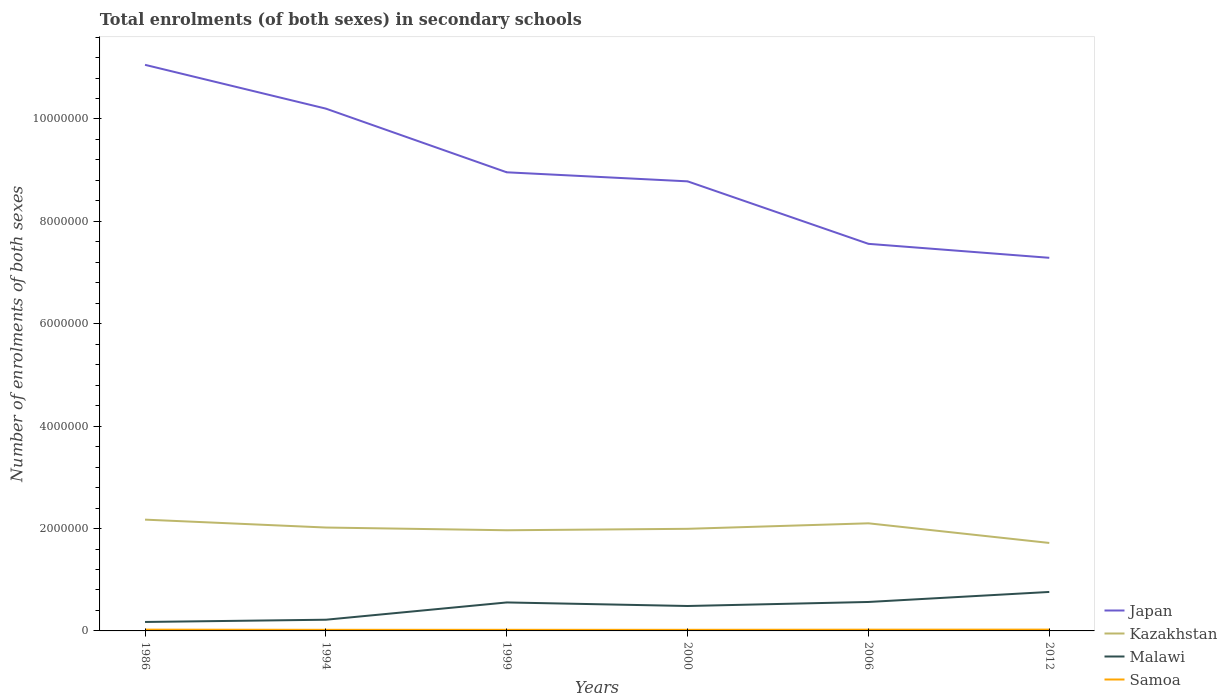How many different coloured lines are there?
Give a very brief answer. 4. Across all years, what is the maximum number of enrolments in secondary schools in Samoa?
Ensure brevity in your answer.  2.17e+04. What is the total number of enrolments in secondary schools in Samoa in the graph?
Provide a succinct answer. -3773. What is the difference between the highest and the second highest number of enrolments in secondary schools in Japan?
Your response must be concise. 3.77e+06. Is the number of enrolments in secondary schools in Malawi strictly greater than the number of enrolments in secondary schools in Kazakhstan over the years?
Ensure brevity in your answer.  Yes. How many lines are there?
Give a very brief answer. 4. How many years are there in the graph?
Give a very brief answer. 6. Does the graph contain any zero values?
Your answer should be compact. No. Does the graph contain grids?
Make the answer very short. No. What is the title of the graph?
Give a very brief answer. Total enrolments (of both sexes) in secondary schools. Does "Nepal" appear as one of the legend labels in the graph?
Make the answer very short. No. What is the label or title of the X-axis?
Provide a short and direct response. Years. What is the label or title of the Y-axis?
Make the answer very short. Number of enrolments of both sexes. What is the Number of enrolments of both sexes in Japan in 1986?
Provide a succinct answer. 1.11e+07. What is the Number of enrolments of both sexes in Kazakhstan in 1986?
Make the answer very short. 2.17e+06. What is the Number of enrolments of both sexes in Malawi in 1986?
Give a very brief answer. 1.75e+05. What is the Number of enrolments of both sexes of Samoa in 1986?
Make the answer very short. 2.51e+04. What is the Number of enrolments of both sexes in Japan in 1994?
Your response must be concise. 1.02e+07. What is the Number of enrolments of both sexes of Kazakhstan in 1994?
Your answer should be very brief. 2.02e+06. What is the Number of enrolments of both sexes in Malawi in 1994?
Provide a short and direct response. 2.19e+05. What is the Number of enrolments of both sexes of Samoa in 1994?
Keep it short and to the point. 2.18e+04. What is the Number of enrolments of both sexes in Japan in 1999?
Your answer should be very brief. 8.96e+06. What is the Number of enrolments of both sexes of Kazakhstan in 1999?
Offer a terse response. 1.97e+06. What is the Number of enrolments of both sexes in Malawi in 1999?
Provide a short and direct response. 5.56e+05. What is the Number of enrolments of both sexes of Samoa in 1999?
Offer a terse response. 2.17e+04. What is the Number of enrolments of both sexes in Japan in 2000?
Ensure brevity in your answer.  8.78e+06. What is the Number of enrolments of both sexes of Kazakhstan in 2000?
Make the answer very short. 1.99e+06. What is the Number of enrolments of both sexes in Malawi in 2000?
Keep it short and to the point. 4.87e+05. What is the Number of enrolments of both sexes in Samoa in 2000?
Ensure brevity in your answer.  2.17e+04. What is the Number of enrolments of both sexes of Japan in 2006?
Offer a very short reply. 7.56e+06. What is the Number of enrolments of both sexes in Kazakhstan in 2006?
Provide a short and direct response. 2.10e+06. What is the Number of enrolments of both sexes of Malawi in 2006?
Offer a very short reply. 5.65e+05. What is the Number of enrolments of both sexes in Samoa in 2006?
Offer a terse response. 2.44e+04. What is the Number of enrolments of both sexes of Japan in 2012?
Provide a short and direct response. 7.29e+06. What is the Number of enrolments of both sexes in Kazakhstan in 2012?
Provide a short and direct response. 1.72e+06. What is the Number of enrolments of both sexes of Malawi in 2012?
Your answer should be compact. 7.61e+05. What is the Number of enrolments of both sexes of Samoa in 2012?
Provide a short and direct response. 2.56e+04. Across all years, what is the maximum Number of enrolments of both sexes of Japan?
Offer a terse response. 1.11e+07. Across all years, what is the maximum Number of enrolments of both sexes in Kazakhstan?
Your response must be concise. 2.17e+06. Across all years, what is the maximum Number of enrolments of both sexes of Malawi?
Make the answer very short. 7.61e+05. Across all years, what is the maximum Number of enrolments of both sexes of Samoa?
Give a very brief answer. 2.56e+04. Across all years, what is the minimum Number of enrolments of both sexes of Japan?
Give a very brief answer. 7.29e+06. Across all years, what is the minimum Number of enrolments of both sexes in Kazakhstan?
Ensure brevity in your answer.  1.72e+06. Across all years, what is the minimum Number of enrolments of both sexes in Malawi?
Provide a short and direct response. 1.75e+05. Across all years, what is the minimum Number of enrolments of both sexes in Samoa?
Provide a short and direct response. 2.17e+04. What is the total Number of enrolments of both sexes of Japan in the graph?
Your response must be concise. 5.39e+07. What is the total Number of enrolments of both sexes in Kazakhstan in the graph?
Offer a terse response. 1.20e+07. What is the total Number of enrolments of both sexes of Malawi in the graph?
Ensure brevity in your answer.  2.76e+06. What is the total Number of enrolments of both sexes of Samoa in the graph?
Offer a very short reply. 1.40e+05. What is the difference between the Number of enrolments of both sexes in Japan in 1986 and that in 1994?
Make the answer very short. 8.56e+05. What is the difference between the Number of enrolments of both sexes in Kazakhstan in 1986 and that in 1994?
Ensure brevity in your answer.  1.54e+05. What is the difference between the Number of enrolments of both sexes in Malawi in 1986 and that in 1994?
Offer a terse response. -4.40e+04. What is the difference between the Number of enrolments of both sexes of Samoa in 1986 and that in 1994?
Your answer should be very brief. 3304. What is the difference between the Number of enrolments of both sexes of Japan in 1986 and that in 1999?
Your response must be concise. 2.10e+06. What is the difference between the Number of enrolments of both sexes of Kazakhstan in 1986 and that in 1999?
Your answer should be very brief. 2.07e+05. What is the difference between the Number of enrolments of both sexes of Malawi in 1986 and that in 1999?
Provide a succinct answer. -3.82e+05. What is the difference between the Number of enrolments of both sexes of Samoa in 1986 and that in 1999?
Keep it short and to the point. 3347. What is the difference between the Number of enrolments of both sexes of Japan in 1986 and that in 2000?
Offer a very short reply. 2.28e+06. What is the difference between the Number of enrolments of both sexes in Kazakhstan in 1986 and that in 2000?
Keep it short and to the point. 1.79e+05. What is the difference between the Number of enrolments of both sexes in Malawi in 1986 and that in 2000?
Offer a very short reply. -3.12e+05. What is the difference between the Number of enrolments of both sexes in Samoa in 1986 and that in 2000?
Ensure brevity in your answer.  3414. What is the difference between the Number of enrolments of both sexes in Japan in 1986 and that in 2006?
Keep it short and to the point. 3.50e+06. What is the difference between the Number of enrolments of both sexes of Kazakhstan in 1986 and that in 2006?
Keep it short and to the point. 7.17e+04. What is the difference between the Number of enrolments of both sexes in Malawi in 1986 and that in 2006?
Give a very brief answer. -3.91e+05. What is the difference between the Number of enrolments of both sexes in Samoa in 1986 and that in 2006?
Your answer should be compact. 705. What is the difference between the Number of enrolments of both sexes of Japan in 1986 and that in 2012?
Make the answer very short. 3.77e+06. What is the difference between the Number of enrolments of both sexes of Kazakhstan in 1986 and that in 2012?
Ensure brevity in your answer.  4.55e+05. What is the difference between the Number of enrolments of both sexes of Malawi in 1986 and that in 2012?
Keep it short and to the point. -5.87e+05. What is the difference between the Number of enrolments of both sexes of Samoa in 1986 and that in 2012?
Provide a short and direct response. -469. What is the difference between the Number of enrolments of both sexes in Japan in 1994 and that in 1999?
Make the answer very short. 1.24e+06. What is the difference between the Number of enrolments of both sexes of Kazakhstan in 1994 and that in 1999?
Make the answer very short. 5.32e+04. What is the difference between the Number of enrolments of both sexes in Malawi in 1994 and that in 1999?
Your response must be concise. -3.38e+05. What is the difference between the Number of enrolments of both sexes in Samoa in 1994 and that in 1999?
Your answer should be very brief. 43. What is the difference between the Number of enrolments of both sexes of Japan in 1994 and that in 2000?
Offer a terse response. 1.42e+06. What is the difference between the Number of enrolments of both sexes of Kazakhstan in 1994 and that in 2000?
Provide a short and direct response. 2.52e+04. What is the difference between the Number of enrolments of both sexes of Malawi in 1994 and that in 2000?
Keep it short and to the point. -2.68e+05. What is the difference between the Number of enrolments of both sexes of Samoa in 1994 and that in 2000?
Your response must be concise. 110. What is the difference between the Number of enrolments of both sexes of Japan in 1994 and that in 2006?
Ensure brevity in your answer.  2.64e+06. What is the difference between the Number of enrolments of both sexes in Kazakhstan in 1994 and that in 2006?
Your answer should be very brief. -8.25e+04. What is the difference between the Number of enrolments of both sexes of Malawi in 1994 and that in 2006?
Provide a succinct answer. -3.47e+05. What is the difference between the Number of enrolments of both sexes in Samoa in 1994 and that in 2006?
Your answer should be very brief. -2599. What is the difference between the Number of enrolments of both sexes in Japan in 1994 and that in 2012?
Offer a very short reply. 2.91e+06. What is the difference between the Number of enrolments of both sexes in Kazakhstan in 1994 and that in 2012?
Your response must be concise. 3.01e+05. What is the difference between the Number of enrolments of both sexes of Malawi in 1994 and that in 2012?
Offer a terse response. -5.43e+05. What is the difference between the Number of enrolments of both sexes of Samoa in 1994 and that in 2012?
Your answer should be very brief. -3773. What is the difference between the Number of enrolments of both sexes of Japan in 1999 and that in 2000?
Provide a short and direct response. 1.77e+05. What is the difference between the Number of enrolments of both sexes of Kazakhstan in 1999 and that in 2000?
Ensure brevity in your answer.  -2.80e+04. What is the difference between the Number of enrolments of both sexes of Malawi in 1999 and that in 2000?
Make the answer very short. 6.95e+04. What is the difference between the Number of enrolments of both sexes of Japan in 1999 and that in 2006?
Your answer should be compact. 1.40e+06. What is the difference between the Number of enrolments of both sexes of Kazakhstan in 1999 and that in 2006?
Your answer should be very brief. -1.36e+05. What is the difference between the Number of enrolments of both sexes in Malawi in 1999 and that in 2006?
Keep it short and to the point. -9145. What is the difference between the Number of enrolments of both sexes of Samoa in 1999 and that in 2006?
Your answer should be very brief. -2642. What is the difference between the Number of enrolments of both sexes in Japan in 1999 and that in 2012?
Give a very brief answer. 1.67e+06. What is the difference between the Number of enrolments of both sexes of Kazakhstan in 1999 and that in 2012?
Offer a very short reply. 2.48e+05. What is the difference between the Number of enrolments of both sexes in Malawi in 1999 and that in 2012?
Your response must be concise. -2.05e+05. What is the difference between the Number of enrolments of both sexes in Samoa in 1999 and that in 2012?
Give a very brief answer. -3816. What is the difference between the Number of enrolments of both sexes of Japan in 2000 and that in 2006?
Make the answer very short. 1.22e+06. What is the difference between the Number of enrolments of both sexes of Kazakhstan in 2000 and that in 2006?
Provide a succinct answer. -1.08e+05. What is the difference between the Number of enrolments of both sexes in Malawi in 2000 and that in 2006?
Provide a short and direct response. -7.87e+04. What is the difference between the Number of enrolments of both sexes in Samoa in 2000 and that in 2006?
Offer a very short reply. -2709. What is the difference between the Number of enrolments of both sexes in Japan in 2000 and that in 2012?
Offer a very short reply. 1.49e+06. What is the difference between the Number of enrolments of both sexes of Kazakhstan in 2000 and that in 2012?
Offer a terse response. 2.76e+05. What is the difference between the Number of enrolments of both sexes in Malawi in 2000 and that in 2012?
Give a very brief answer. -2.75e+05. What is the difference between the Number of enrolments of both sexes of Samoa in 2000 and that in 2012?
Offer a terse response. -3883. What is the difference between the Number of enrolments of both sexes of Japan in 2006 and that in 2012?
Give a very brief answer. 2.73e+05. What is the difference between the Number of enrolments of both sexes of Kazakhstan in 2006 and that in 2012?
Provide a succinct answer. 3.84e+05. What is the difference between the Number of enrolments of both sexes in Malawi in 2006 and that in 2012?
Provide a short and direct response. -1.96e+05. What is the difference between the Number of enrolments of both sexes of Samoa in 2006 and that in 2012?
Give a very brief answer. -1174. What is the difference between the Number of enrolments of both sexes in Japan in 1986 and the Number of enrolments of both sexes in Kazakhstan in 1994?
Make the answer very short. 9.04e+06. What is the difference between the Number of enrolments of both sexes in Japan in 1986 and the Number of enrolments of both sexes in Malawi in 1994?
Make the answer very short. 1.08e+07. What is the difference between the Number of enrolments of both sexes in Japan in 1986 and the Number of enrolments of both sexes in Samoa in 1994?
Offer a terse response. 1.10e+07. What is the difference between the Number of enrolments of both sexes in Kazakhstan in 1986 and the Number of enrolments of both sexes in Malawi in 1994?
Give a very brief answer. 1.96e+06. What is the difference between the Number of enrolments of both sexes in Kazakhstan in 1986 and the Number of enrolments of both sexes in Samoa in 1994?
Keep it short and to the point. 2.15e+06. What is the difference between the Number of enrolments of both sexes in Malawi in 1986 and the Number of enrolments of both sexes in Samoa in 1994?
Your response must be concise. 1.53e+05. What is the difference between the Number of enrolments of both sexes in Japan in 1986 and the Number of enrolments of both sexes in Kazakhstan in 1999?
Ensure brevity in your answer.  9.09e+06. What is the difference between the Number of enrolments of both sexes of Japan in 1986 and the Number of enrolments of both sexes of Malawi in 1999?
Provide a short and direct response. 1.05e+07. What is the difference between the Number of enrolments of both sexes of Japan in 1986 and the Number of enrolments of both sexes of Samoa in 1999?
Your answer should be compact. 1.10e+07. What is the difference between the Number of enrolments of both sexes in Kazakhstan in 1986 and the Number of enrolments of both sexes in Malawi in 1999?
Make the answer very short. 1.62e+06. What is the difference between the Number of enrolments of both sexes of Kazakhstan in 1986 and the Number of enrolments of both sexes of Samoa in 1999?
Provide a short and direct response. 2.15e+06. What is the difference between the Number of enrolments of both sexes of Malawi in 1986 and the Number of enrolments of both sexes of Samoa in 1999?
Ensure brevity in your answer.  1.53e+05. What is the difference between the Number of enrolments of both sexes of Japan in 1986 and the Number of enrolments of both sexes of Kazakhstan in 2000?
Your answer should be very brief. 9.06e+06. What is the difference between the Number of enrolments of both sexes in Japan in 1986 and the Number of enrolments of both sexes in Malawi in 2000?
Give a very brief answer. 1.06e+07. What is the difference between the Number of enrolments of both sexes in Japan in 1986 and the Number of enrolments of both sexes in Samoa in 2000?
Your answer should be compact. 1.10e+07. What is the difference between the Number of enrolments of both sexes in Kazakhstan in 1986 and the Number of enrolments of both sexes in Malawi in 2000?
Give a very brief answer. 1.69e+06. What is the difference between the Number of enrolments of both sexes of Kazakhstan in 1986 and the Number of enrolments of both sexes of Samoa in 2000?
Offer a terse response. 2.15e+06. What is the difference between the Number of enrolments of both sexes of Malawi in 1986 and the Number of enrolments of both sexes of Samoa in 2000?
Make the answer very short. 1.53e+05. What is the difference between the Number of enrolments of both sexes in Japan in 1986 and the Number of enrolments of both sexes in Kazakhstan in 2006?
Give a very brief answer. 8.96e+06. What is the difference between the Number of enrolments of both sexes of Japan in 1986 and the Number of enrolments of both sexes of Malawi in 2006?
Provide a short and direct response. 1.05e+07. What is the difference between the Number of enrolments of both sexes of Japan in 1986 and the Number of enrolments of both sexes of Samoa in 2006?
Your answer should be compact. 1.10e+07. What is the difference between the Number of enrolments of both sexes of Kazakhstan in 1986 and the Number of enrolments of both sexes of Malawi in 2006?
Ensure brevity in your answer.  1.61e+06. What is the difference between the Number of enrolments of both sexes of Kazakhstan in 1986 and the Number of enrolments of both sexes of Samoa in 2006?
Your answer should be compact. 2.15e+06. What is the difference between the Number of enrolments of both sexes in Malawi in 1986 and the Number of enrolments of both sexes in Samoa in 2006?
Provide a short and direct response. 1.50e+05. What is the difference between the Number of enrolments of both sexes in Japan in 1986 and the Number of enrolments of both sexes in Kazakhstan in 2012?
Offer a very short reply. 9.34e+06. What is the difference between the Number of enrolments of both sexes of Japan in 1986 and the Number of enrolments of both sexes of Malawi in 2012?
Make the answer very short. 1.03e+07. What is the difference between the Number of enrolments of both sexes in Japan in 1986 and the Number of enrolments of both sexes in Samoa in 2012?
Give a very brief answer. 1.10e+07. What is the difference between the Number of enrolments of both sexes in Kazakhstan in 1986 and the Number of enrolments of both sexes in Malawi in 2012?
Offer a very short reply. 1.41e+06. What is the difference between the Number of enrolments of both sexes of Kazakhstan in 1986 and the Number of enrolments of both sexes of Samoa in 2012?
Your answer should be very brief. 2.15e+06. What is the difference between the Number of enrolments of both sexes in Malawi in 1986 and the Number of enrolments of both sexes in Samoa in 2012?
Provide a succinct answer. 1.49e+05. What is the difference between the Number of enrolments of both sexes in Japan in 1994 and the Number of enrolments of both sexes in Kazakhstan in 1999?
Offer a terse response. 8.24e+06. What is the difference between the Number of enrolments of both sexes in Japan in 1994 and the Number of enrolments of both sexes in Malawi in 1999?
Offer a terse response. 9.65e+06. What is the difference between the Number of enrolments of both sexes of Japan in 1994 and the Number of enrolments of both sexes of Samoa in 1999?
Provide a short and direct response. 1.02e+07. What is the difference between the Number of enrolments of both sexes in Kazakhstan in 1994 and the Number of enrolments of both sexes in Malawi in 1999?
Ensure brevity in your answer.  1.46e+06. What is the difference between the Number of enrolments of both sexes of Kazakhstan in 1994 and the Number of enrolments of both sexes of Samoa in 1999?
Offer a terse response. 2.00e+06. What is the difference between the Number of enrolments of both sexes of Malawi in 1994 and the Number of enrolments of both sexes of Samoa in 1999?
Keep it short and to the point. 1.97e+05. What is the difference between the Number of enrolments of both sexes of Japan in 1994 and the Number of enrolments of both sexes of Kazakhstan in 2000?
Provide a succinct answer. 8.21e+06. What is the difference between the Number of enrolments of both sexes in Japan in 1994 and the Number of enrolments of both sexes in Malawi in 2000?
Give a very brief answer. 9.72e+06. What is the difference between the Number of enrolments of both sexes of Japan in 1994 and the Number of enrolments of both sexes of Samoa in 2000?
Keep it short and to the point. 1.02e+07. What is the difference between the Number of enrolments of both sexes of Kazakhstan in 1994 and the Number of enrolments of both sexes of Malawi in 2000?
Provide a short and direct response. 1.53e+06. What is the difference between the Number of enrolments of both sexes in Kazakhstan in 1994 and the Number of enrolments of both sexes in Samoa in 2000?
Provide a succinct answer. 2.00e+06. What is the difference between the Number of enrolments of both sexes of Malawi in 1994 and the Number of enrolments of both sexes of Samoa in 2000?
Your answer should be compact. 1.97e+05. What is the difference between the Number of enrolments of both sexes in Japan in 1994 and the Number of enrolments of both sexes in Kazakhstan in 2006?
Make the answer very short. 8.10e+06. What is the difference between the Number of enrolments of both sexes in Japan in 1994 and the Number of enrolments of both sexes in Malawi in 2006?
Offer a terse response. 9.64e+06. What is the difference between the Number of enrolments of both sexes in Japan in 1994 and the Number of enrolments of both sexes in Samoa in 2006?
Make the answer very short. 1.02e+07. What is the difference between the Number of enrolments of both sexes in Kazakhstan in 1994 and the Number of enrolments of both sexes in Malawi in 2006?
Provide a short and direct response. 1.45e+06. What is the difference between the Number of enrolments of both sexes in Kazakhstan in 1994 and the Number of enrolments of both sexes in Samoa in 2006?
Provide a succinct answer. 2.00e+06. What is the difference between the Number of enrolments of both sexes in Malawi in 1994 and the Number of enrolments of both sexes in Samoa in 2006?
Provide a succinct answer. 1.94e+05. What is the difference between the Number of enrolments of both sexes of Japan in 1994 and the Number of enrolments of both sexes of Kazakhstan in 2012?
Offer a terse response. 8.48e+06. What is the difference between the Number of enrolments of both sexes of Japan in 1994 and the Number of enrolments of both sexes of Malawi in 2012?
Your answer should be very brief. 9.44e+06. What is the difference between the Number of enrolments of both sexes in Japan in 1994 and the Number of enrolments of both sexes in Samoa in 2012?
Give a very brief answer. 1.02e+07. What is the difference between the Number of enrolments of both sexes in Kazakhstan in 1994 and the Number of enrolments of both sexes in Malawi in 2012?
Your answer should be compact. 1.26e+06. What is the difference between the Number of enrolments of both sexes of Kazakhstan in 1994 and the Number of enrolments of both sexes of Samoa in 2012?
Offer a terse response. 1.99e+06. What is the difference between the Number of enrolments of both sexes of Malawi in 1994 and the Number of enrolments of both sexes of Samoa in 2012?
Offer a terse response. 1.93e+05. What is the difference between the Number of enrolments of both sexes in Japan in 1999 and the Number of enrolments of both sexes in Kazakhstan in 2000?
Your answer should be very brief. 6.96e+06. What is the difference between the Number of enrolments of both sexes in Japan in 1999 and the Number of enrolments of both sexes in Malawi in 2000?
Your answer should be compact. 8.47e+06. What is the difference between the Number of enrolments of both sexes of Japan in 1999 and the Number of enrolments of both sexes of Samoa in 2000?
Ensure brevity in your answer.  8.94e+06. What is the difference between the Number of enrolments of both sexes in Kazakhstan in 1999 and the Number of enrolments of both sexes in Malawi in 2000?
Ensure brevity in your answer.  1.48e+06. What is the difference between the Number of enrolments of both sexes of Kazakhstan in 1999 and the Number of enrolments of both sexes of Samoa in 2000?
Your answer should be very brief. 1.94e+06. What is the difference between the Number of enrolments of both sexes in Malawi in 1999 and the Number of enrolments of both sexes in Samoa in 2000?
Your response must be concise. 5.35e+05. What is the difference between the Number of enrolments of both sexes in Japan in 1999 and the Number of enrolments of both sexes in Kazakhstan in 2006?
Your answer should be very brief. 6.86e+06. What is the difference between the Number of enrolments of both sexes in Japan in 1999 and the Number of enrolments of both sexes in Malawi in 2006?
Ensure brevity in your answer.  8.39e+06. What is the difference between the Number of enrolments of both sexes of Japan in 1999 and the Number of enrolments of both sexes of Samoa in 2006?
Offer a very short reply. 8.93e+06. What is the difference between the Number of enrolments of both sexes in Kazakhstan in 1999 and the Number of enrolments of both sexes in Malawi in 2006?
Give a very brief answer. 1.40e+06. What is the difference between the Number of enrolments of both sexes in Kazakhstan in 1999 and the Number of enrolments of both sexes in Samoa in 2006?
Your answer should be compact. 1.94e+06. What is the difference between the Number of enrolments of both sexes in Malawi in 1999 and the Number of enrolments of both sexes in Samoa in 2006?
Your answer should be very brief. 5.32e+05. What is the difference between the Number of enrolments of both sexes in Japan in 1999 and the Number of enrolments of both sexes in Kazakhstan in 2012?
Your answer should be very brief. 7.24e+06. What is the difference between the Number of enrolments of both sexes in Japan in 1999 and the Number of enrolments of both sexes in Malawi in 2012?
Offer a very short reply. 8.20e+06. What is the difference between the Number of enrolments of both sexes in Japan in 1999 and the Number of enrolments of both sexes in Samoa in 2012?
Make the answer very short. 8.93e+06. What is the difference between the Number of enrolments of both sexes of Kazakhstan in 1999 and the Number of enrolments of both sexes of Malawi in 2012?
Your response must be concise. 1.21e+06. What is the difference between the Number of enrolments of both sexes of Kazakhstan in 1999 and the Number of enrolments of both sexes of Samoa in 2012?
Make the answer very short. 1.94e+06. What is the difference between the Number of enrolments of both sexes in Malawi in 1999 and the Number of enrolments of both sexes in Samoa in 2012?
Your answer should be very brief. 5.31e+05. What is the difference between the Number of enrolments of both sexes in Japan in 2000 and the Number of enrolments of both sexes in Kazakhstan in 2006?
Your answer should be very brief. 6.68e+06. What is the difference between the Number of enrolments of both sexes in Japan in 2000 and the Number of enrolments of both sexes in Malawi in 2006?
Offer a very short reply. 8.22e+06. What is the difference between the Number of enrolments of both sexes of Japan in 2000 and the Number of enrolments of both sexes of Samoa in 2006?
Ensure brevity in your answer.  8.76e+06. What is the difference between the Number of enrolments of both sexes in Kazakhstan in 2000 and the Number of enrolments of both sexes in Malawi in 2006?
Your response must be concise. 1.43e+06. What is the difference between the Number of enrolments of both sexes in Kazakhstan in 2000 and the Number of enrolments of both sexes in Samoa in 2006?
Your answer should be very brief. 1.97e+06. What is the difference between the Number of enrolments of both sexes of Malawi in 2000 and the Number of enrolments of both sexes of Samoa in 2006?
Keep it short and to the point. 4.62e+05. What is the difference between the Number of enrolments of both sexes of Japan in 2000 and the Number of enrolments of both sexes of Kazakhstan in 2012?
Make the answer very short. 7.06e+06. What is the difference between the Number of enrolments of both sexes of Japan in 2000 and the Number of enrolments of both sexes of Malawi in 2012?
Your answer should be very brief. 8.02e+06. What is the difference between the Number of enrolments of both sexes in Japan in 2000 and the Number of enrolments of both sexes in Samoa in 2012?
Your response must be concise. 8.76e+06. What is the difference between the Number of enrolments of both sexes in Kazakhstan in 2000 and the Number of enrolments of both sexes in Malawi in 2012?
Offer a very short reply. 1.23e+06. What is the difference between the Number of enrolments of both sexes of Kazakhstan in 2000 and the Number of enrolments of both sexes of Samoa in 2012?
Your answer should be compact. 1.97e+06. What is the difference between the Number of enrolments of both sexes of Malawi in 2000 and the Number of enrolments of both sexes of Samoa in 2012?
Provide a short and direct response. 4.61e+05. What is the difference between the Number of enrolments of both sexes in Japan in 2006 and the Number of enrolments of both sexes in Kazakhstan in 2012?
Keep it short and to the point. 5.84e+06. What is the difference between the Number of enrolments of both sexes in Japan in 2006 and the Number of enrolments of both sexes in Malawi in 2012?
Make the answer very short. 6.80e+06. What is the difference between the Number of enrolments of both sexes in Japan in 2006 and the Number of enrolments of both sexes in Samoa in 2012?
Offer a very short reply. 7.54e+06. What is the difference between the Number of enrolments of both sexes in Kazakhstan in 2006 and the Number of enrolments of both sexes in Malawi in 2012?
Keep it short and to the point. 1.34e+06. What is the difference between the Number of enrolments of both sexes of Kazakhstan in 2006 and the Number of enrolments of both sexes of Samoa in 2012?
Your answer should be compact. 2.08e+06. What is the difference between the Number of enrolments of both sexes of Malawi in 2006 and the Number of enrolments of both sexes of Samoa in 2012?
Your answer should be compact. 5.40e+05. What is the average Number of enrolments of both sexes of Japan per year?
Keep it short and to the point. 8.98e+06. What is the average Number of enrolments of both sexes in Kazakhstan per year?
Your answer should be very brief. 2.00e+06. What is the average Number of enrolments of both sexes in Malawi per year?
Make the answer very short. 4.61e+05. What is the average Number of enrolments of both sexes of Samoa per year?
Provide a succinct answer. 2.34e+04. In the year 1986, what is the difference between the Number of enrolments of both sexes in Japan and Number of enrolments of both sexes in Kazakhstan?
Ensure brevity in your answer.  8.88e+06. In the year 1986, what is the difference between the Number of enrolments of both sexes in Japan and Number of enrolments of both sexes in Malawi?
Provide a short and direct response. 1.09e+07. In the year 1986, what is the difference between the Number of enrolments of both sexes in Japan and Number of enrolments of both sexes in Samoa?
Your response must be concise. 1.10e+07. In the year 1986, what is the difference between the Number of enrolments of both sexes in Kazakhstan and Number of enrolments of both sexes in Malawi?
Your answer should be very brief. 2.00e+06. In the year 1986, what is the difference between the Number of enrolments of both sexes in Kazakhstan and Number of enrolments of both sexes in Samoa?
Make the answer very short. 2.15e+06. In the year 1986, what is the difference between the Number of enrolments of both sexes in Malawi and Number of enrolments of both sexes in Samoa?
Your answer should be very brief. 1.50e+05. In the year 1994, what is the difference between the Number of enrolments of both sexes of Japan and Number of enrolments of both sexes of Kazakhstan?
Offer a very short reply. 8.18e+06. In the year 1994, what is the difference between the Number of enrolments of both sexes in Japan and Number of enrolments of both sexes in Malawi?
Provide a short and direct response. 9.98e+06. In the year 1994, what is the difference between the Number of enrolments of both sexes in Japan and Number of enrolments of both sexes in Samoa?
Offer a terse response. 1.02e+07. In the year 1994, what is the difference between the Number of enrolments of both sexes of Kazakhstan and Number of enrolments of both sexes of Malawi?
Offer a terse response. 1.80e+06. In the year 1994, what is the difference between the Number of enrolments of both sexes of Kazakhstan and Number of enrolments of both sexes of Samoa?
Keep it short and to the point. 2.00e+06. In the year 1994, what is the difference between the Number of enrolments of both sexes of Malawi and Number of enrolments of both sexes of Samoa?
Your answer should be compact. 1.97e+05. In the year 1999, what is the difference between the Number of enrolments of both sexes in Japan and Number of enrolments of both sexes in Kazakhstan?
Your answer should be very brief. 6.99e+06. In the year 1999, what is the difference between the Number of enrolments of both sexes in Japan and Number of enrolments of both sexes in Malawi?
Make the answer very short. 8.40e+06. In the year 1999, what is the difference between the Number of enrolments of both sexes in Japan and Number of enrolments of both sexes in Samoa?
Provide a short and direct response. 8.94e+06. In the year 1999, what is the difference between the Number of enrolments of both sexes in Kazakhstan and Number of enrolments of both sexes in Malawi?
Provide a succinct answer. 1.41e+06. In the year 1999, what is the difference between the Number of enrolments of both sexes of Kazakhstan and Number of enrolments of both sexes of Samoa?
Offer a terse response. 1.94e+06. In the year 1999, what is the difference between the Number of enrolments of both sexes of Malawi and Number of enrolments of both sexes of Samoa?
Ensure brevity in your answer.  5.35e+05. In the year 2000, what is the difference between the Number of enrolments of both sexes in Japan and Number of enrolments of both sexes in Kazakhstan?
Your answer should be very brief. 6.79e+06. In the year 2000, what is the difference between the Number of enrolments of both sexes in Japan and Number of enrolments of both sexes in Malawi?
Make the answer very short. 8.30e+06. In the year 2000, what is the difference between the Number of enrolments of both sexes of Japan and Number of enrolments of both sexes of Samoa?
Your response must be concise. 8.76e+06. In the year 2000, what is the difference between the Number of enrolments of both sexes in Kazakhstan and Number of enrolments of both sexes in Malawi?
Give a very brief answer. 1.51e+06. In the year 2000, what is the difference between the Number of enrolments of both sexes in Kazakhstan and Number of enrolments of both sexes in Samoa?
Provide a short and direct response. 1.97e+06. In the year 2000, what is the difference between the Number of enrolments of both sexes in Malawi and Number of enrolments of both sexes in Samoa?
Provide a succinct answer. 4.65e+05. In the year 2006, what is the difference between the Number of enrolments of both sexes of Japan and Number of enrolments of both sexes of Kazakhstan?
Your answer should be very brief. 5.46e+06. In the year 2006, what is the difference between the Number of enrolments of both sexes of Japan and Number of enrolments of both sexes of Malawi?
Your response must be concise. 7.00e+06. In the year 2006, what is the difference between the Number of enrolments of both sexes in Japan and Number of enrolments of both sexes in Samoa?
Offer a terse response. 7.54e+06. In the year 2006, what is the difference between the Number of enrolments of both sexes of Kazakhstan and Number of enrolments of both sexes of Malawi?
Ensure brevity in your answer.  1.54e+06. In the year 2006, what is the difference between the Number of enrolments of both sexes of Kazakhstan and Number of enrolments of both sexes of Samoa?
Offer a terse response. 2.08e+06. In the year 2006, what is the difference between the Number of enrolments of both sexes in Malawi and Number of enrolments of both sexes in Samoa?
Your answer should be compact. 5.41e+05. In the year 2012, what is the difference between the Number of enrolments of both sexes of Japan and Number of enrolments of both sexes of Kazakhstan?
Keep it short and to the point. 5.57e+06. In the year 2012, what is the difference between the Number of enrolments of both sexes of Japan and Number of enrolments of both sexes of Malawi?
Ensure brevity in your answer.  6.53e+06. In the year 2012, what is the difference between the Number of enrolments of both sexes in Japan and Number of enrolments of both sexes in Samoa?
Provide a succinct answer. 7.26e+06. In the year 2012, what is the difference between the Number of enrolments of both sexes in Kazakhstan and Number of enrolments of both sexes in Malawi?
Make the answer very short. 9.57e+05. In the year 2012, what is the difference between the Number of enrolments of both sexes in Kazakhstan and Number of enrolments of both sexes in Samoa?
Provide a succinct answer. 1.69e+06. In the year 2012, what is the difference between the Number of enrolments of both sexes in Malawi and Number of enrolments of both sexes in Samoa?
Provide a short and direct response. 7.36e+05. What is the ratio of the Number of enrolments of both sexes in Japan in 1986 to that in 1994?
Give a very brief answer. 1.08. What is the ratio of the Number of enrolments of both sexes in Kazakhstan in 1986 to that in 1994?
Make the answer very short. 1.08. What is the ratio of the Number of enrolments of both sexes of Malawi in 1986 to that in 1994?
Give a very brief answer. 0.8. What is the ratio of the Number of enrolments of both sexes in Samoa in 1986 to that in 1994?
Your answer should be compact. 1.15. What is the ratio of the Number of enrolments of both sexes of Japan in 1986 to that in 1999?
Keep it short and to the point. 1.23. What is the ratio of the Number of enrolments of both sexes of Kazakhstan in 1986 to that in 1999?
Give a very brief answer. 1.11. What is the ratio of the Number of enrolments of both sexes of Malawi in 1986 to that in 1999?
Offer a very short reply. 0.31. What is the ratio of the Number of enrolments of both sexes in Samoa in 1986 to that in 1999?
Ensure brevity in your answer.  1.15. What is the ratio of the Number of enrolments of both sexes in Japan in 1986 to that in 2000?
Your answer should be very brief. 1.26. What is the ratio of the Number of enrolments of both sexes of Kazakhstan in 1986 to that in 2000?
Provide a short and direct response. 1.09. What is the ratio of the Number of enrolments of both sexes of Malawi in 1986 to that in 2000?
Offer a terse response. 0.36. What is the ratio of the Number of enrolments of both sexes of Samoa in 1986 to that in 2000?
Offer a very short reply. 1.16. What is the ratio of the Number of enrolments of both sexes in Japan in 1986 to that in 2006?
Provide a short and direct response. 1.46. What is the ratio of the Number of enrolments of both sexes of Kazakhstan in 1986 to that in 2006?
Provide a short and direct response. 1.03. What is the ratio of the Number of enrolments of both sexes of Malawi in 1986 to that in 2006?
Offer a very short reply. 0.31. What is the ratio of the Number of enrolments of both sexes of Samoa in 1986 to that in 2006?
Offer a very short reply. 1.03. What is the ratio of the Number of enrolments of both sexes of Japan in 1986 to that in 2012?
Give a very brief answer. 1.52. What is the ratio of the Number of enrolments of both sexes in Kazakhstan in 1986 to that in 2012?
Offer a very short reply. 1.27. What is the ratio of the Number of enrolments of both sexes of Malawi in 1986 to that in 2012?
Provide a short and direct response. 0.23. What is the ratio of the Number of enrolments of both sexes in Samoa in 1986 to that in 2012?
Ensure brevity in your answer.  0.98. What is the ratio of the Number of enrolments of both sexes in Japan in 1994 to that in 1999?
Provide a succinct answer. 1.14. What is the ratio of the Number of enrolments of both sexes of Kazakhstan in 1994 to that in 1999?
Your answer should be very brief. 1.03. What is the ratio of the Number of enrolments of both sexes in Malawi in 1994 to that in 1999?
Your answer should be compact. 0.39. What is the ratio of the Number of enrolments of both sexes of Samoa in 1994 to that in 1999?
Ensure brevity in your answer.  1. What is the ratio of the Number of enrolments of both sexes of Japan in 1994 to that in 2000?
Offer a terse response. 1.16. What is the ratio of the Number of enrolments of both sexes of Kazakhstan in 1994 to that in 2000?
Offer a very short reply. 1.01. What is the ratio of the Number of enrolments of both sexes in Malawi in 1994 to that in 2000?
Provide a succinct answer. 0.45. What is the ratio of the Number of enrolments of both sexes in Japan in 1994 to that in 2006?
Make the answer very short. 1.35. What is the ratio of the Number of enrolments of both sexes in Kazakhstan in 1994 to that in 2006?
Your response must be concise. 0.96. What is the ratio of the Number of enrolments of both sexes of Malawi in 1994 to that in 2006?
Your answer should be compact. 0.39. What is the ratio of the Number of enrolments of both sexes in Samoa in 1994 to that in 2006?
Make the answer very short. 0.89. What is the ratio of the Number of enrolments of both sexes of Japan in 1994 to that in 2012?
Offer a terse response. 1.4. What is the ratio of the Number of enrolments of both sexes in Kazakhstan in 1994 to that in 2012?
Provide a short and direct response. 1.18. What is the ratio of the Number of enrolments of both sexes in Malawi in 1994 to that in 2012?
Offer a terse response. 0.29. What is the ratio of the Number of enrolments of both sexes in Samoa in 1994 to that in 2012?
Ensure brevity in your answer.  0.85. What is the ratio of the Number of enrolments of both sexes of Japan in 1999 to that in 2000?
Your answer should be very brief. 1.02. What is the ratio of the Number of enrolments of both sexes in Malawi in 1999 to that in 2000?
Offer a terse response. 1.14. What is the ratio of the Number of enrolments of both sexes of Samoa in 1999 to that in 2000?
Keep it short and to the point. 1. What is the ratio of the Number of enrolments of both sexes of Japan in 1999 to that in 2006?
Keep it short and to the point. 1.18. What is the ratio of the Number of enrolments of both sexes of Kazakhstan in 1999 to that in 2006?
Your response must be concise. 0.94. What is the ratio of the Number of enrolments of both sexes in Malawi in 1999 to that in 2006?
Ensure brevity in your answer.  0.98. What is the ratio of the Number of enrolments of both sexes in Samoa in 1999 to that in 2006?
Provide a short and direct response. 0.89. What is the ratio of the Number of enrolments of both sexes of Japan in 1999 to that in 2012?
Offer a very short reply. 1.23. What is the ratio of the Number of enrolments of both sexes of Kazakhstan in 1999 to that in 2012?
Your answer should be compact. 1.14. What is the ratio of the Number of enrolments of both sexes in Malawi in 1999 to that in 2012?
Offer a very short reply. 0.73. What is the ratio of the Number of enrolments of both sexes in Samoa in 1999 to that in 2012?
Your response must be concise. 0.85. What is the ratio of the Number of enrolments of both sexes of Japan in 2000 to that in 2006?
Provide a short and direct response. 1.16. What is the ratio of the Number of enrolments of both sexes of Kazakhstan in 2000 to that in 2006?
Your response must be concise. 0.95. What is the ratio of the Number of enrolments of both sexes in Malawi in 2000 to that in 2006?
Your answer should be compact. 0.86. What is the ratio of the Number of enrolments of both sexes in Japan in 2000 to that in 2012?
Ensure brevity in your answer.  1.2. What is the ratio of the Number of enrolments of both sexes in Kazakhstan in 2000 to that in 2012?
Provide a succinct answer. 1.16. What is the ratio of the Number of enrolments of both sexes in Malawi in 2000 to that in 2012?
Make the answer very short. 0.64. What is the ratio of the Number of enrolments of both sexes of Samoa in 2000 to that in 2012?
Offer a terse response. 0.85. What is the ratio of the Number of enrolments of both sexes in Japan in 2006 to that in 2012?
Keep it short and to the point. 1.04. What is the ratio of the Number of enrolments of both sexes in Kazakhstan in 2006 to that in 2012?
Provide a succinct answer. 1.22. What is the ratio of the Number of enrolments of both sexes in Malawi in 2006 to that in 2012?
Ensure brevity in your answer.  0.74. What is the ratio of the Number of enrolments of both sexes of Samoa in 2006 to that in 2012?
Keep it short and to the point. 0.95. What is the difference between the highest and the second highest Number of enrolments of both sexes in Japan?
Keep it short and to the point. 8.56e+05. What is the difference between the highest and the second highest Number of enrolments of both sexes of Kazakhstan?
Offer a terse response. 7.17e+04. What is the difference between the highest and the second highest Number of enrolments of both sexes of Malawi?
Provide a short and direct response. 1.96e+05. What is the difference between the highest and the second highest Number of enrolments of both sexes of Samoa?
Keep it short and to the point. 469. What is the difference between the highest and the lowest Number of enrolments of both sexes in Japan?
Offer a very short reply. 3.77e+06. What is the difference between the highest and the lowest Number of enrolments of both sexes of Kazakhstan?
Ensure brevity in your answer.  4.55e+05. What is the difference between the highest and the lowest Number of enrolments of both sexes in Malawi?
Give a very brief answer. 5.87e+05. What is the difference between the highest and the lowest Number of enrolments of both sexes of Samoa?
Your answer should be compact. 3883. 